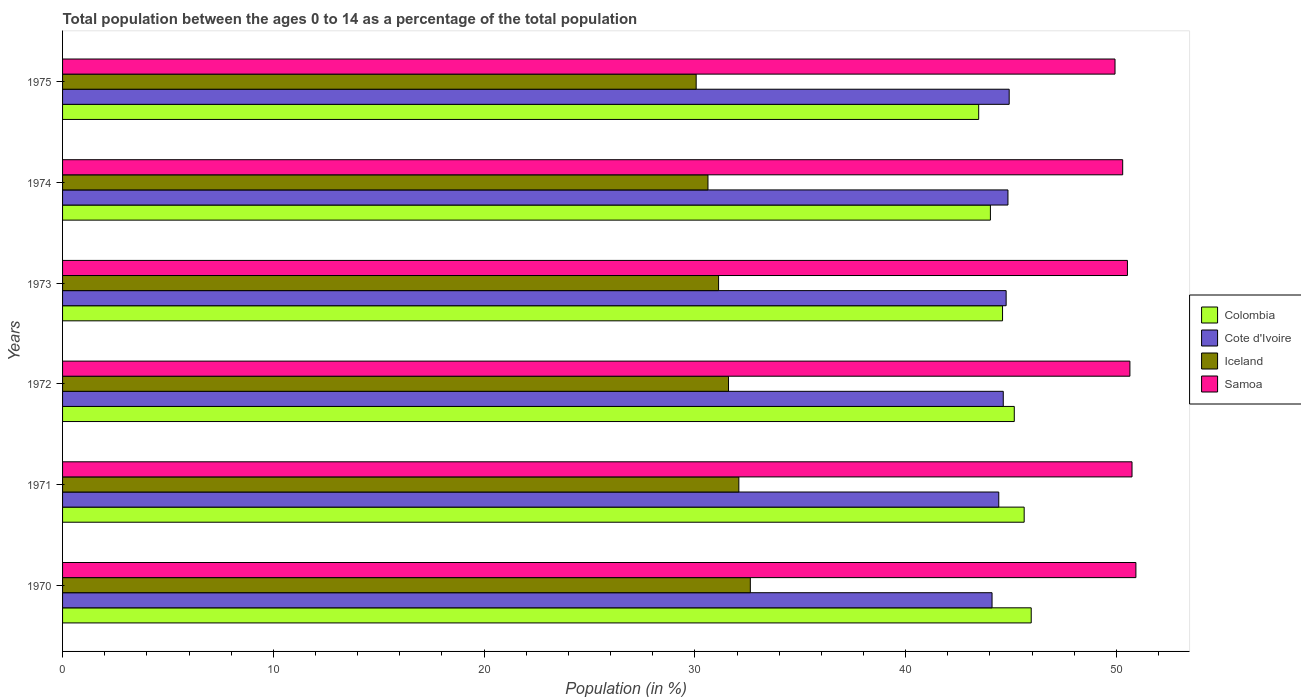Are the number of bars on each tick of the Y-axis equal?
Keep it short and to the point. Yes. How many bars are there on the 2nd tick from the top?
Ensure brevity in your answer.  4. In how many cases, is the number of bars for a given year not equal to the number of legend labels?
Offer a very short reply. 0. What is the percentage of the population ages 0 to 14 in Cote d'Ivoire in 1971?
Ensure brevity in your answer.  44.42. Across all years, what is the maximum percentage of the population ages 0 to 14 in Colombia?
Offer a terse response. 45.96. Across all years, what is the minimum percentage of the population ages 0 to 14 in Samoa?
Your answer should be very brief. 49.94. In which year was the percentage of the population ages 0 to 14 in Samoa minimum?
Provide a short and direct response. 1975. What is the total percentage of the population ages 0 to 14 in Samoa in the graph?
Ensure brevity in your answer.  303.07. What is the difference between the percentage of the population ages 0 to 14 in Colombia in 1973 and that in 1975?
Keep it short and to the point. 1.13. What is the difference between the percentage of the population ages 0 to 14 in Samoa in 1975 and the percentage of the population ages 0 to 14 in Cote d'Ivoire in 1974?
Make the answer very short. 5.08. What is the average percentage of the population ages 0 to 14 in Samoa per year?
Your answer should be very brief. 50.51. In the year 1970, what is the difference between the percentage of the population ages 0 to 14 in Cote d'Ivoire and percentage of the population ages 0 to 14 in Iceland?
Your answer should be very brief. 11.47. What is the ratio of the percentage of the population ages 0 to 14 in Iceland in 1971 to that in 1973?
Provide a succinct answer. 1.03. Is the difference between the percentage of the population ages 0 to 14 in Cote d'Ivoire in 1971 and 1973 greater than the difference between the percentage of the population ages 0 to 14 in Iceland in 1971 and 1973?
Provide a short and direct response. No. What is the difference between the highest and the second highest percentage of the population ages 0 to 14 in Iceland?
Ensure brevity in your answer.  0.54. What is the difference between the highest and the lowest percentage of the population ages 0 to 14 in Samoa?
Provide a short and direct response. 0.99. In how many years, is the percentage of the population ages 0 to 14 in Cote d'Ivoire greater than the average percentage of the population ages 0 to 14 in Cote d'Ivoire taken over all years?
Your answer should be very brief. 4. Is the sum of the percentage of the population ages 0 to 14 in Iceland in 1971 and 1975 greater than the maximum percentage of the population ages 0 to 14 in Cote d'Ivoire across all years?
Keep it short and to the point. Yes. Is it the case that in every year, the sum of the percentage of the population ages 0 to 14 in Colombia and percentage of the population ages 0 to 14 in Iceland is greater than the sum of percentage of the population ages 0 to 14 in Samoa and percentage of the population ages 0 to 14 in Cote d'Ivoire?
Provide a succinct answer. Yes. What does the 1st bar from the top in 1970 represents?
Your answer should be very brief. Samoa. What does the 4th bar from the bottom in 1972 represents?
Provide a succinct answer. Samoa. Is it the case that in every year, the sum of the percentage of the population ages 0 to 14 in Iceland and percentage of the population ages 0 to 14 in Colombia is greater than the percentage of the population ages 0 to 14 in Samoa?
Ensure brevity in your answer.  Yes. Are all the bars in the graph horizontal?
Ensure brevity in your answer.  Yes. What is the difference between two consecutive major ticks on the X-axis?
Give a very brief answer. 10. Are the values on the major ticks of X-axis written in scientific E-notation?
Offer a very short reply. No. How are the legend labels stacked?
Give a very brief answer. Vertical. What is the title of the graph?
Ensure brevity in your answer.  Total population between the ages 0 to 14 as a percentage of the total population. Does "Romania" appear as one of the legend labels in the graph?
Your response must be concise. No. What is the label or title of the X-axis?
Offer a terse response. Population (in %). What is the label or title of the Y-axis?
Provide a succinct answer. Years. What is the Population (in %) in Colombia in 1970?
Give a very brief answer. 45.96. What is the Population (in %) in Cote d'Ivoire in 1970?
Your answer should be compact. 44.1. What is the Population (in %) in Iceland in 1970?
Provide a short and direct response. 32.63. What is the Population (in %) in Samoa in 1970?
Your answer should be compact. 50.93. What is the Population (in %) in Colombia in 1971?
Offer a very short reply. 45.62. What is the Population (in %) of Cote d'Ivoire in 1971?
Give a very brief answer. 44.42. What is the Population (in %) in Iceland in 1971?
Offer a very short reply. 32.09. What is the Population (in %) in Samoa in 1971?
Keep it short and to the point. 50.74. What is the Population (in %) in Colombia in 1972?
Provide a short and direct response. 45.16. What is the Population (in %) of Cote d'Ivoire in 1972?
Your answer should be compact. 44.63. What is the Population (in %) in Iceland in 1972?
Offer a terse response. 31.6. What is the Population (in %) in Samoa in 1972?
Keep it short and to the point. 50.64. What is the Population (in %) of Colombia in 1973?
Provide a short and direct response. 44.6. What is the Population (in %) in Cote d'Ivoire in 1973?
Make the answer very short. 44.77. What is the Population (in %) in Iceland in 1973?
Your response must be concise. 31.13. What is the Population (in %) of Samoa in 1973?
Provide a succinct answer. 50.52. What is the Population (in %) of Colombia in 1974?
Ensure brevity in your answer.  44.02. What is the Population (in %) in Cote d'Ivoire in 1974?
Make the answer very short. 44.86. What is the Population (in %) of Iceland in 1974?
Your answer should be compact. 30.62. What is the Population (in %) of Samoa in 1974?
Ensure brevity in your answer.  50.3. What is the Population (in %) of Colombia in 1975?
Provide a succinct answer. 43.47. What is the Population (in %) in Cote d'Ivoire in 1975?
Offer a terse response. 44.91. What is the Population (in %) in Iceland in 1975?
Offer a terse response. 30.06. What is the Population (in %) in Samoa in 1975?
Provide a short and direct response. 49.94. Across all years, what is the maximum Population (in %) of Colombia?
Give a very brief answer. 45.96. Across all years, what is the maximum Population (in %) in Cote d'Ivoire?
Give a very brief answer. 44.91. Across all years, what is the maximum Population (in %) of Iceland?
Ensure brevity in your answer.  32.63. Across all years, what is the maximum Population (in %) of Samoa?
Give a very brief answer. 50.93. Across all years, what is the minimum Population (in %) of Colombia?
Offer a terse response. 43.47. Across all years, what is the minimum Population (in %) in Cote d'Ivoire?
Ensure brevity in your answer.  44.1. Across all years, what is the minimum Population (in %) in Iceland?
Ensure brevity in your answer.  30.06. Across all years, what is the minimum Population (in %) of Samoa?
Offer a very short reply. 49.94. What is the total Population (in %) of Colombia in the graph?
Offer a very short reply. 268.83. What is the total Population (in %) of Cote d'Ivoire in the graph?
Offer a very short reply. 267.69. What is the total Population (in %) in Iceland in the graph?
Offer a very short reply. 188.13. What is the total Population (in %) of Samoa in the graph?
Offer a very short reply. 303.07. What is the difference between the Population (in %) in Colombia in 1970 and that in 1971?
Provide a succinct answer. 0.34. What is the difference between the Population (in %) in Cote d'Ivoire in 1970 and that in 1971?
Give a very brief answer. -0.32. What is the difference between the Population (in %) in Iceland in 1970 and that in 1971?
Ensure brevity in your answer.  0.55. What is the difference between the Population (in %) in Samoa in 1970 and that in 1971?
Give a very brief answer. 0.18. What is the difference between the Population (in %) in Colombia in 1970 and that in 1972?
Your response must be concise. 0.8. What is the difference between the Population (in %) in Cote d'Ivoire in 1970 and that in 1972?
Your answer should be compact. -0.53. What is the difference between the Population (in %) of Iceland in 1970 and that in 1972?
Your answer should be compact. 1.03. What is the difference between the Population (in %) in Samoa in 1970 and that in 1972?
Give a very brief answer. 0.28. What is the difference between the Population (in %) in Colombia in 1970 and that in 1973?
Keep it short and to the point. 1.36. What is the difference between the Population (in %) in Cote d'Ivoire in 1970 and that in 1973?
Give a very brief answer. -0.67. What is the difference between the Population (in %) of Iceland in 1970 and that in 1973?
Provide a succinct answer. 1.51. What is the difference between the Population (in %) in Samoa in 1970 and that in 1973?
Offer a terse response. 0.4. What is the difference between the Population (in %) of Colombia in 1970 and that in 1974?
Offer a very short reply. 1.94. What is the difference between the Population (in %) of Cote d'Ivoire in 1970 and that in 1974?
Ensure brevity in your answer.  -0.76. What is the difference between the Population (in %) in Iceland in 1970 and that in 1974?
Make the answer very short. 2.01. What is the difference between the Population (in %) in Samoa in 1970 and that in 1974?
Your answer should be compact. 0.63. What is the difference between the Population (in %) of Colombia in 1970 and that in 1975?
Ensure brevity in your answer.  2.49. What is the difference between the Population (in %) of Cote d'Ivoire in 1970 and that in 1975?
Give a very brief answer. -0.81. What is the difference between the Population (in %) of Iceland in 1970 and that in 1975?
Keep it short and to the point. 2.57. What is the difference between the Population (in %) of Samoa in 1970 and that in 1975?
Provide a short and direct response. 0.99. What is the difference between the Population (in %) in Colombia in 1971 and that in 1972?
Ensure brevity in your answer.  0.47. What is the difference between the Population (in %) in Cote d'Ivoire in 1971 and that in 1972?
Your response must be concise. -0.21. What is the difference between the Population (in %) in Iceland in 1971 and that in 1972?
Give a very brief answer. 0.49. What is the difference between the Population (in %) of Samoa in 1971 and that in 1972?
Offer a terse response. 0.1. What is the difference between the Population (in %) of Colombia in 1971 and that in 1973?
Keep it short and to the point. 1.03. What is the difference between the Population (in %) in Cote d'Ivoire in 1971 and that in 1973?
Offer a very short reply. -0.35. What is the difference between the Population (in %) of Iceland in 1971 and that in 1973?
Ensure brevity in your answer.  0.96. What is the difference between the Population (in %) of Samoa in 1971 and that in 1973?
Give a very brief answer. 0.22. What is the difference between the Population (in %) of Colombia in 1971 and that in 1974?
Offer a terse response. 1.6. What is the difference between the Population (in %) in Cote d'Ivoire in 1971 and that in 1974?
Offer a terse response. -0.44. What is the difference between the Population (in %) of Iceland in 1971 and that in 1974?
Provide a succinct answer. 1.46. What is the difference between the Population (in %) of Samoa in 1971 and that in 1974?
Provide a succinct answer. 0.44. What is the difference between the Population (in %) of Colombia in 1971 and that in 1975?
Your answer should be very brief. 2.16. What is the difference between the Population (in %) of Cote d'Ivoire in 1971 and that in 1975?
Ensure brevity in your answer.  -0.49. What is the difference between the Population (in %) in Iceland in 1971 and that in 1975?
Offer a terse response. 2.02. What is the difference between the Population (in %) of Samoa in 1971 and that in 1975?
Make the answer very short. 0.81. What is the difference between the Population (in %) in Colombia in 1972 and that in 1973?
Provide a short and direct response. 0.56. What is the difference between the Population (in %) of Cote d'Ivoire in 1972 and that in 1973?
Keep it short and to the point. -0.14. What is the difference between the Population (in %) in Iceland in 1972 and that in 1973?
Give a very brief answer. 0.47. What is the difference between the Population (in %) of Samoa in 1972 and that in 1973?
Give a very brief answer. 0.12. What is the difference between the Population (in %) of Colombia in 1972 and that in 1974?
Give a very brief answer. 1.13. What is the difference between the Population (in %) of Cote d'Ivoire in 1972 and that in 1974?
Give a very brief answer. -0.22. What is the difference between the Population (in %) of Iceland in 1972 and that in 1974?
Provide a succinct answer. 0.97. What is the difference between the Population (in %) in Samoa in 1972 and that in 1974?
Ensure brevity in your answer.  0.34. What is the difference between the Population (in %) of Colombia in 1972 and that in 1975?
Offer a very short reply. 1.69. What is the difference between the Population (in %) in Cote d'Ivoire in 1972 and that in 1975?
Your response must be concise. -0.28. What is the difference between the Population (in %) in Iceland in 1972 and that in 1975?
Provide a succinct answer. 1.53. What is the difference between the Population (in %) of Samoa in 1972 and that in 1975?
Make the answer very short. 0.71. What is the difference between the Population (in %) in Colombia in 1973 and that in 1974?
Your answer should be compact. 0.58. What is the difference between the Population (in %) of Cote d'Ivoire in 1973 and that in 1974?
Provide a short and direct response. -0.09. What is the difference between the Population (in %) of Iceland in 1973 and that in 1974?
Give a very brief answer. 0.5. What is the difference between the Population (in %) in Samoa in 1973 and that in 1974?
Provide a short and direct response. 0.23. What is the difference between the Population (in %) of Colombia in 1973 and that in 1975?
Your response must be concise. 1.13. What is the difference between the Population (in %) in Cote d'Ivoire in 1973 and that in 1975?
Your answer should be very brief. -0.15. What is the difference between the Population (in %) in Iceland in 1973 and that in 1975?
Provide a short and direct response. 1.06. What is the difference between the Population (in %) in Samoa in 1973 and that in 1975?
Your answer should be very brief. 0.59. What is the difference between the Population (in %) in Colombia in 1974 and that in 1975?
Provide a short and direct response. 0.56. What is the difference between the Population (in %) of Cote d'Ivoire in 1974 and that in 1975?
Ensure brevity in your answer.  -0.06. What is the difference between the Population (in %) in Iceland in 1974 and that in 1975?
Make the answer very short. 0.56. What is the difference between the Population (in %) of Samoa in 1974 and that in 1975?
Your response must be concise. 0.36. What is the difference between the Population (in %) of Colombia in 1970 and the Population (in %) of Cote d'Ivoire in 1971?
Give a very brief answer. 1.54. What is the difference between the Population (in %) of Colombia in 1970 and the Population (in %) of Iceland in 1971?
Offer a very short reply. 13.87. What is the difference between the Population (in %) in Colombia in 1970 and the Population (in %) in Samoa in 1971?
Your response must be concise. -4.78. What is the difference between the Population (in %) of Cote d'Ivoire in 1970 and the Population (in %) of Iceland in 1971?
Provide a short and direct response. 12.01. What is the difference between the Population (in %) in Cote d'Ivoire in 1970 and the Population (in %) in Samoa in 1971?
Your answer should be compact. -6.64. What is the difference between the Population (in %) of Iceland in 1970 and the Population (in %) of Samoa in 1971?
Your response must be concise. -18.11. What is the difference between the Population (in %) in Colombia in 1970 and the Population (in %) in Cote d'Ivoire in 1972?
Provide a short and direct response. 1.33. What is the difference between the Population (in %) of Colombia in 1970 and the Population (in %) of Iceland in 1972?
Ensure brevity in your answer.  14.36. What is the difference between the Population (in %) in Colombia in 1970 and the Population (in %) in Samoa in 1972?
Make the answer very short. -4.68. What is the difference between the Population (in %) in Cote d'Ivoire in 1970 and the Population (in %) in Iceland in 1972?
Ensure brevity in your answer.  12.5. What is the difference between the Population (in %) of Cote d'Ivoire in 1970 and the Population (in %) of Samoa in 1972?
Make the answer very short. -6.54. What is the difference between the Population (in %) in Iceland in 1970 and the Population (in %) in Samoa in 1972?
Your answer should be very brief. -18.01. What is the difference between the Population (in %) in Colombia in 1970 and the Population (in %) in Cote d'Ivoire in 1973?
Offer a very short reply. 1.19. What is the difference between the Population (in %) in Colombia in 1970 and the Population (in %) in Iceland in 1973?
Your answer should be very brief. 14.83. What is the difference between the Population (in %) of Colombia in 1970 and the Population (in %) of Samoa in 1973?
Offer a terse response. -4.57. What is the difference between the Population (in %) of Cote d'Ivoire in 1970 and the Population (in %) of Iceland in 1973?
Offer a terse response. 12.97. What is the difference between the Population (in %) of Cote d'Ivoire in 1970 and the Population (in %) of Samoa in 1973?
Your response must be concise. -6.42. What is the difference between the Population (in %) of Iceland in 1970 and the Population (in %) of Samoa in 1973?
Make the answer very short. -17.89. What is the difference between the Population (in %) in Colombia in 1970 and the Population (in %) in Cote d'Ivoire in 1974?
Your answer should be very brief. 1.1. What is the difference between the Population (in %) of Colombia in 1970 and the Population (in %) of Iceland in 1974?
Give a very brief answer. 15.34. What is the difference between the Population (in %) of Colombia in 1970 and the Population (in %) of Samoa in 1974?
Offer a very short reply. -4.34. What is the difference between the Population (in %) of Cote d'Ivoire in 1970 and the Population (in %) of Iceland in 1974?
Offer a very short reply. 13.48. What is the difference between the Population (in %) of Cote d'Ivoire in 1970 and the Population (in %) of Samoa in 1974?
Provide a short and direct response. -6.2. What is the difference between the Population (in %) in Iceland in 1970 and the Population (in %) in Samoa in 1974?
Ensure brevity in your answer.  -17.67. What is the difference between the Population (in %) in Colombia in 1970 and the Population (in %) in Cote d'Ivoire in 1975?
Make the answer very short. 1.05. What is the difference between the Population (in %) of Colombia in 1970 and the Population (in %) of Iceland in 1975?
Make the answer very short. 15.9. What is the difference between the Population (in %) in Colombia in 1970 and the Population (in %) in Samoa in 1975?
Offer a terse response. -3.98. What is the difference between the Population (in %) of Cote d'Ivoire in 1970 and the Population (in %) of Iceland in 1975?
Offer a very short reply. 14.04. What is the difference between the Population (in %) of Cote d'Ivoire in 1970 and the Population (in %) of Samoa in 1975?
Your answer should be compact. -5.83. What is the difference between the Population (in %) in Iceland in 1970 and the Population (in %) in Samoa in 1975?
Your response must be concise. -17.3. What is the difference between the Population (in %) of Colombia in 1971 and the Population (in %) of Cote d'Ivoire in 1972?
Your answer should be compact. 0.99. What is the difference between the Population (in %) of Colombia in 1971 and the Population (in %) of Iceland in 1972?
Provide a succinct answer. 14.03. What is the difference between the Population (in %) in Colombia in 1971 and the Population (in %) in Samoa in 1972?
Keep it short and to the point. -5.02. What is the difference between the Population (in %) in Cote d'Ivoire in 1971 and the Population (in %) in Iceland in 1972?
Offer a terse response. 12.82. What is the difference between the Population (in %) in Cote d'Ivoire in 1971 and the Population (in %) in Samoa in 1972?
Give a very brief answer. -6.22. What is the difference between the Population (in %) in Iceland in 1971 and the Population (in %) in Samoa in 1972?
Provide a succinct answer. -18.55. What is the difference between the Population (in %) in Colombia in 1971 and the Population (in %) in Cote d'Ivoire in 1973?
Provide a succinct answer. 0.86. What is the difference between the Population (in %) in Colombia in 1971 and the Population (in %) in Iceland in 1973?
Keep it short and to the point. 14.5. What is the difference between the Population (in %) in Cote d'Ivoire in 1971 and the Population (in %) in Iceland in 1973?
Your response must be concise. 13.29. What is the difference between the Population (in %) of Cote d'Ivoire in 1971 and the Population (in %) of Samoa in 1973?
Provide a short and direct response. -6.1. What is the difference between the Population (in %) in Iceland in 1971 and the Population (in %) in Samoa in 1973?
Your answer should be very brief. -18.44. What is the difference between the Population (in %) of Colombia in 1971 and the Population (in %) of Cote d'Ivoire in 1974?
Provide a succinct answer. 0.77. What is the difference between the Population (in %) of Colombia in 1971 and the Population (in %) of Iceland in 1974?
Provide a short and direct response. 15. What is the difference between the Population (in %) of Colombia in 1971 and the Population (in %) of Samoa in 1974?
Ensure brevity in your answer.  -4.67. What is the difference between the Population (in %) of Cote d'Ivoire in 1971 and the Population (in %) of Iceland in 1974?
Ensure brevity in your answer.  13.8. What is the difference between the Population (in %) of Cote d'Ivoire in 1971 and the Population (in %) of Samoa in 1974?
Provide a short and direct response. -5.88. What is the difference between the Population (in %) in Iceland in 1971 and the Population (in %) in Samoa in 1974?
Provide a succinct answer. -18.21. What is the difference between the Population (in %) in Colombia in 1971 and the Population (in %) in Cote d'Ivoire in 1975?
Provide a short and direct response. 0.71. What is the difference between the Population (in %) in Colombia in 1971 and the Population (in %) in Iceland in 1975?
Your answer should be compact. 15.56. What is the difference between the Population (in %) in Colombia in 1971 and the Population (in %) in Samoa in 1975?
Provide a short and direct response. -4.31. What is the difference between the Population (in %) of Cote d'Ivoire in 1971 and the Population (in %) of Iceland in 1975?
Make the answer very short. 14.36. What is the difference between the Population (in %) in Cote d'Ivoire in 1971 and the Population (in %) in Samoa in 1975?
Offer a terse response. -5.52. What is the difference between the Population (in %) in Iceland in 1971 and the Population (in %) in Samoa in 1975?
Provide a short and direct response. -17.85. What is the difference between the Population (in %) of Colombia in 1972 and the Population (in %) of Cote d'Ivoire in 1973?
Provide a succinct answer. 0.39. What is the difference between the Population (in %) in Colombia in 1972 and the Population (in %) in Iceland in 1973?
Offer a terse response. 14.03. What is the difference between the Population (in %) of Colombia in 1972 and the Population (in %) of Samoa in 1973?
Provide a succinct answer. -5.37. What is the difference between the Population (in %) of Cote d'Ivoire in 1972 and the Population (in %) of Iceland in 1973?
Keep it short and to the point. 13.51. What is the difference between the Population (in %) of Cote d'Ivoire in 1972 and the Population (in %) of Samoa in 1973?
Give a very brief answer. -5.89. What is the difference between the Population (in %) in Iceland in 1972 and the Population (in %) in Samoa in 1973?
Provide a succinct answer. -18.93. What is the difference between the Population (in %) of Colombia in 1972 and the Population (in %) of Cote d'Ivoire in 1974?
Make the answer very short. 0.3. What is the difference between the Population (in %) of Colombia in 1972 and the Population (in %) of Iceland in 1974?
Your response must be concise. 14.53. What is the difference between the Population (in %) of Colombia in 1972 and the Population (in %) of Samoa in 1974?
Keep it short and to the point. -5.14. What is the difference between the Population (in %) of Cote d'Ivoire in 1972 and the Population (in %) of Iceland in 1974?
Keep it short and to the point. 14.01. What is the difference between the Population (in %) in Cote d'Ivoire in 1972 and the Population (in %) in Samoa in 1974?
Your answer should be very brief. -5.67. What is the difference between the Population (in %) of Iceland in 1972 and the Population (in %) of Samoa in 1974?
Your answer should be very brief. -18.7. What is the difference between the Population (in %) of Colombia in 1972 and the Population (in %) of Cote d'Ivoire in 1975?
Offer a very short reply. 0.24. What is the difference between the Population (in %) in Colombia in 1972 and the Population (in %) in Iceland in 1975?
Your answer should be compact. 15.09. What is the difference between the Population (in %) of Colombia in 1972 and the Population (in %) of Samoa in 1975?
Ensure brevity in your answer.  -4.78. What is the difference between the Population (in %) of Cote d'Ivoire in 1972 and the Population (in %) of Iceland in 1975?
Your response must be concise. 14.57. What is the difference between the Population (in %) in Cote d'Ivoire in 1972 and the Population (in %) in Samoa in 1975?
Offer a very short reply. -5.3. What is the difference between the Population (in %) of Iceland in 1972 and the Population (in %) of Samoa in 1975?
Your answer should be very brief. -18.34. What is the difference between the Population (in %) in Colombia in 1973 and the Population (in %) in Cote d'Ivoire in 1974?
Ensure brevity in your answer.  -0.26. What is the difference between the Population (in %) in Colombia in 1973 and the Population (in %) in Iceland in 1974?
Make the answer very short. 13.98. What is the difference between the Population (in %) of Colombia in 1973 and the Population (in %) of Samoa in 1974?
Give a very brief answer. -5.7. What is the difference between the Population (in %) of Cote d'Ivoire in 1973 and the Population (in %) of Iceland in 1974?
Offer a very short reply. 14.15. What is the difference between the Population (in %) of Cote d'Ivoire in 1973 and the Population (in %) of Samoa in 1974?
Your answer should be very brief. -5.53. What is the difference between the Population (in %) in Iceland in 1973 and the Population (in %) in Samoa in 1974?
Provide a short and direct response. -19.17. What is the difference between the Population (in %) of Colombia in 1973 and the Population (in %) of Cote d'Ivoire in 1975?
Offer a very short reply. -0.31. What is the difference between the Population (in %) of Colombia in 1973 and the Population (in %) of Iceland in 1975?
Your answer should be very brief. 14.54. What is the difference between the Population (in %) in Colombia in 1973 and the Population (in %) in Samoa in 1975?
Ensure brevity in your answer.  -5.34. What is the difference between the Population (in %) in Cote d'Ivoire in 1973 and the Population (in %) in Iceland in 1975?
Your answer should be very brief. 14.71. What is the difference between the Population (in %) of Cote d'Ivoire in 1973 and the Population (in %) of Samoa in 1975?
Make the answer very short. -5.17. What is the difference between the Population (in %) in Iceland in 1973 and the Population (in %) in Samoa in 1975?
Provide a succinct answer. -18.81. What is the difference between the Population (in %) in Colombia in 1974 and the Population (in %) in Cote d'Ivoire in 1975?
Provide a short and direct response. -0.89. What is the difference between the Population (in %) of Colombia in 1974 and the Population (in %) of Iceland in 1975?
Your response must be concise. 13.96. What is the difference between the Population (in %) of Colombia in 1974 and the Population (in %) of Samoa in 1975?
Keep it short and to the point. -5.91. What is the difference between the Population (in %) of Cote d'Ivoire in 1974 and the Population (in %) of Iceland in 1975?
Keep it short and to the point. 14.79. What is the difference between the Population (in %) of Cote d'Ivoire in 1974 and the Population (in %) of Samoa in 1975?
Ensure brevity in your answer.  -5.08. What is the difference between the Population (in %) of Iceland in 1974 and the Population (in %) of Samoa in 1975?
Give a very brief answer. -19.31. What is the average Population (in %) in Colombia per year?
Provide a short and direct response. 44.81. What is the average Population (in %) in Cote d'Ivoire per year?
Your answer should be compact. 44.62. What is the average Population (in %) in Iceland per year?
Provide a short and direct response. 31.35. What is the average Population (in %) of Samoa per year?
Keep it short and to the point. 50.51. In the year 1970, what is the difference between the Population (in %) of Colombia and Population (in %) of Cote d'Ivoire?
Give a very brief answer. 1.86. In the year 1970, what is the difference between the Population (in %) in Colombia and Population (in %) in Iceland?
Provide a short and direct response. 13.33. In the year 1970, what is the difference between the Population (in %) in Colombia and Population (in %) in Samoa?
Your answer should be very brief. -4.97. In the year 1970, what is the difference between the Population (in %) in Cote d'Ivoire and Population (in %) in Iceland?
Provide a short and direct response. 11.47. In the year 1970, what is the difference between the Population (in %) in Cote d'Ivoire and Population (in %) in Samoa?
Make the answer very short. -6.83. In the year 1970, what is the difference between the Population (in %) in Iceland and Population (in %) in Samoa?
Offer a terse response. -18.29. In the year 1971, what is the difference between the Population (in %) of Colombia and Population (in %) of Cote d'Ivoire?
Your response must be concise. 1.2. In the year 1971, what is the difference between the Population (in %) in Colombia and Population (in %) in Iceland?
Give a very brief answer. 13.54. In the year 1971, what is the difference between the Population (in %) in Colombia and Population (in %) in Samoa?
Make the answer very short. -5.12. In the year 1971, what is the difference between the Population (in %) in Cote d'Ivoire and Population (in %) in Iceland?
Give a very brief answer. 12.33. In the year 1971, what is the difference between the Population (in %) in Cote d'Ivoire and Population (in %) in Samoa?
Offer a very short reply. -6.32. In the year 1971, what is the difference between the Population (in %) in Iceland and Population (in %) in Samoa?
Your response must be concise. -18.66. In the year 1972, what is the difference between the Population (in %) of Colombia and Population (in %) of Cote d'Ivoire?
Keep it short and to the point. 0.52. In the year 1972, what is the difference between the Population (in %) of Colombia and Population (in %) of Iceland?
Your response must be concise. 13.56. In the year 1972, what is the difference between the Population (in %) of Colombia and Population (in %) of Samoa?
Your response must be concise. -5.49. In the year 1972, what is the difference between the Population (in %) in Cote d'Ivoire and Population (in %) in Iceland?
Provide a short and direct response. 13.04. In the year 1972, what is the difference between the Population (in %) in Cote d'Ivoire and Population (in %) in Samoa?
Provide a short and direct response. -6.01. In the year 1972, what is the difference between the Population (in %) in Iceland and Population (in %) in Samoa?
Offer a very short reply. -19.04. In the year 1973, what is the difference between the Population (in %) of Colombia and Population (in %) of Cote d'Ivoire?
Give a very brief answer. -0.17. In the year 1973, what is the difference between the Population (in %) in Colombia and Population (in %) in Iceland?
Your answer should be compact. 13.47. In the year 1973, what is the difference between the Population (in %) in Colombia and Population (in %) in Samoa?
Provide a short and direct response. -5.93. In the year 1973, what is the difference between the Population (in %) in Cote d'Ivoire and Population (in %) in Iceland?
Offer a very short reply. 13.64. In the year 1973, what is the difference between the Population (in %) in Cote d'Ivoire and Population (in %) in Samoa?
Offer a very short reply. -5.76. In the year 1973, what is the difference between the Population (in %) of Iceland and Population (in %) of Samoa?
Keep it short and to the point. -19.4. In the year 1974, what is the difference between the Population (in %) in Colombia and Population (in %) in Cote d'Ivoire?
Give a very brief answer. -0.83. In the year 1974, what is the difference between the Population (in %) of Colombia and Population (in %) of Iceland?
Your answer should be very brief. 13.4. In the year 1974, what is the difference between the Population (in %) in Colombia and Population (in %) in Samoa?
Make the answer very short. -6.28. In the year 1974, what is the difference between the Population (in %) of Cote d'Ivoire and Population (in %) of Iceland?
Give a very brief answer. 14.23. In the year 1974, what is the difference between the Population (in %) of Cote d'Ivoire and Population (in %) of Samoa?
Provide a short and direct response. -5.44. In the year 1974, what is the difference between the Population (in %) of Iceland and Population (in %) of Samoa?
Give a very brief answer. -19.68. In the year 1975, what is the difference between the Population (in %) of Colombia and Population (in %) of Cote d'Ivoire?
Provide a short and direct response. -1.45. In the year 1975, what is the difference between the Population (in %) of Colombia and Population (in %) of Iceland?
Give a very brief answer. 13.4. In the year 1975, what is the difference between the Population (in %) of Colombia and Population (in %) of Samoa?
Ensure brevity in your answer.  -6.47. In the year 1975, what is the difference between the Population (in %) in Cote d'Ivoire and Population (in %) in Iceland?
Your answer should be compact. 14.85. In the year 1975, what is the difference between the Population (in %) of Cote d'Ivoire and Population (in %) of Samoa?
Make the answer very short. -5.02. In the year 1975, what is the difference between the Population (in %) in Iceland and Population (in %) in Samoa?
Offer a very short reply. -19.87. What is the ratio of the Population (in %) of Colombia in 1970 to that in 1971?
Offer a terse response. 1.01. What is the ratio of the Population (in %) in Cote d'Ivoire in 1970 to that in 1971?
Give a very brief answer. 0.99. What is the ratio of the Population (in %) in Samoa in 1970 to that in 1971?
Provide a short and direct response. 1. What is the ratio of the Population (in %) in Colombia in 1970 to that in 1972?
Give a very brief answer. 1.02. What is the ratio of the Population (in %) in Cote d'Ivoire in 1970 to that in 1972?
Offer a terse response. 0.99. What is the ratio of the Population (in %) of Iceland in 1970 to that in 1972?
Your response must be concise. 1.03. What is the ratio of the Population (in %) of Samoa in 1970 to that in 1972?
Offer a very short reply. 1.01. What is the ratio of the Population (in %) in Colombia in 1970 to that in 1973?
Make the answer very short. 1.03. What is the ratio of the Population (in %) of Cote d'Ivoire in 1970 to that in 1973?
Your response must be concise. 0.99. What is the ratio of the Population (in %) in Iceland in 1970 to that in 1973?
Your response must be concise. 1.05. What is the ratio of the Population (in %) of Samoa in 1970 to that in 1973?
Offer a terse response. 1.01. What is the ratio of the Population (in %) of Colombia in 1970 to that in 1974?
Provide a succinct answer. 1.04. What is the ratio of the Population (in %) of Cote d'Ivoire in 1970 to that in 1974?
Keep it short and to the point. 0.98. What is the ratio of the Population (in %) in Iceland in 1970 to that in 1974?
Make the answer very short. 1.07. What is the ratio of the Population (in %) of Samoa in 1970 to that in 1974?
Make the answer very short. 1.01. What is the ratio of the Population (in %) in Colombia in 1970 to that in 1975?
Provide a short and direct response. 1.06. What is the ratio of the Population (in %) in Cote d'Ivoire in 1970 to that in 1975?
Offer a terse response. 0.98. What is the ratio of the Population (in %) in Iceland in 1970 to that in 1975?
Offer a terse response. 1.09. What is the ratio of the Population (in %) in Samoa in 1970 to that in 1975?
Give a very brief answer. 1.02. What is the ratio of the Population (in %) of Colombia in 1971 to that in 1972?
Your response must be concise. 1.01. What is the ratio of the Population (in %) of Iceland in 1971 to that in 1972?
Offer a very short reply. 1.02. What is the ratio of the Population (in %) in Samoa in 1971 to that in 1972?
Keep it short and to the point. 1. What is the ratio of the Population (in %) in Colombia in 1971 to that in 1973?
Your answer should be very brief. 1.02. What is the ratio of the Population (in %) in Cote d'Ivoire in 1971 to that in 1973?
Offer a very short reply. 0.99. What is the ratio of the Population (in %) of Iceland in 1971 to that in 1973?
Your answer should be very brief. 1.03. What is the ratio of the Population (in %) of Colombia in 1971 to that in 1974?
Your response must be concise. 1.04. What is the ratio of the Population (in %) of Cote d'Ivoire in 1971 to that in 1974?
Provide a short and direct response. 0.99. What is the ratio of the Population (in %) in Iceland in 1971 to that in 1974?
Make the answer very short. 1.05. What is the ratio of the Population (in %) in Samoa in 1971 to that in 1974?
Keep it short and to the point. 1.01. What is the ratio of the Population (in %) of Colombia in 1971 to that in 1975?
Your answer should be compact. 1.05. What is the ratio of the Population (in %) in Cote d'Ivoire in 1971 to that in 1975?
Your response must be concise. 0.99. What is the ratio of the Population (in %) in Iceland in 1971 to that in 1975?
Provide a succinct answer. 1.07. What is the ratio of the Population (in %) in Samoa in 1971 to that in 1975?
Offer a very short reply. 1.02. What is the ratio of the Population (in %) of Colombia in 1972 to that in 1973?
Make the answer very short. 1.01. What is the ratio of the Population (in %) of Cote d'Ivoire in 1972 to that in 1973?
Keep it short and to the point. 1. What is the ratio of the Population (in %) of Iceland in 1972 to that in 1973?
Keep it short and to the point. 1.02. What is the ratio of the Population (in %) in Samoa in 1972 to that in 1973?
Make the answer very short. 1. What is the ratio of the Population (in %) of Colombia in 1972 to that in 1974?
Offer a terse response. 1.03. What is the ratio of the Population (in %) in Iceland in 1972 to that in 1974?
Provide a succinct answer. 1.03. What is the ratio of the Population (in %) of Samoa in 1972 to that in 1974?
Provide a short and direct response. 1.01. What is the ratio of the Population (in %) in Colombia in 1972 to that in 1975?
Keep it short and to the point. 1.04. What is the ratio of the Population (in %) in Cote d'Ivoire in 1972 to that in 1975?
Make the answer very short. 0.99. What is the ratio of the Population (in %) of Iceland in 1972 to that in 1975?
Ensure brevity in your answer.  1.05. What is the ratio of the Population (in %) in Samoa in 1972 to that in 1975?
Give a very brief answer. 1.01. What is the ratio of the Population (in %) in Colombia in 1973 to that in 1974?
Keep it short and to the point. 1.01. What is the ratio of the Population (in %) of Cote d'Ivoire in 1973 to that in 1974?
Your answer should be compact. 1. What is the ratio of the Population (in %) in Iceland in 1973 to that in 1974?
Offer a very short reply. 1.02. What is the ratio of the Population (in %) of Colombia in 1973 to that in 1975?
Offer a very short reply. 1.03. What is the ratio of the Population (in %) of Cote d'Ivoire in 1973 to that in 1975?
Offer a very short reply. 1. What is the ratio of the Population (in %) in Iceland in 1973 to that in 1975?
Provide a short and direct response. 1.04. What is the ratio of the Population (in %) in Samoa in 1973 to that in 1975?
Make the answer very short. 1.01. What is the ratio of the Population (in %) in Colombia in 1974 to that in 1975?
Your answer should be very brief. 1.01. What is the ratio of the Population (in %) in Iceland in 1974 to that in 1975?
Offer a terse response. 1.02. What is the ratio of the Population (in %) of Samoa in 1974 to that in 1975?
Offer a terse response. 1.01. What is the difference between the highest and the second highest Population (in %) of Colombia?
Offer a terse response. 0.34. What is the difference between the highest and the second highest Population (in %) in Cote d'Ivoire?
Ensure brevity in your answer.  0.06. What is the difference between the highest and the second highest Population (in %) in Iceland?
Offer a terse response. 0.55. What is the difference between the highest and the second highest Population (in %) of Samoa?
Provide a succinct answer. 0.18. What is the difference between the highest and the lowest Population (in %) of Colombia?
Your answer should be very brief. 2.49. What is the difference between the highest and the lowest Population (in %) in Cote d'Ivoire?
Your answer should be compact. 0.81. What is the difference between the highest and the lowest Population (in %) in Iceland?
Provide a short and direct response. 2.57. What is the difference between the highest and the lowest Population (in %) of Samoa?
Make the answer very short. 0.99. 